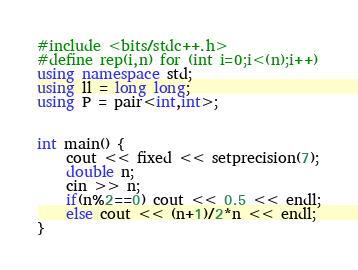Convert code to text. <code><loc_0><loc_0><loc_500><loc_500><_C++_>#include <bits/stdc++.h>
#define rep(i,n) for (int i=0;i<(n);i++)
using namespace std;
using ll = long long;
using P = pair<int,int>;
 
 
int main() {
    cout << fixed << setprecision(7);
    double n;
    cin >> n;
    if(n%2==0) cout << 0.5 << endl;
    else cout << (n+1)/2*n << endl;
}</code> 